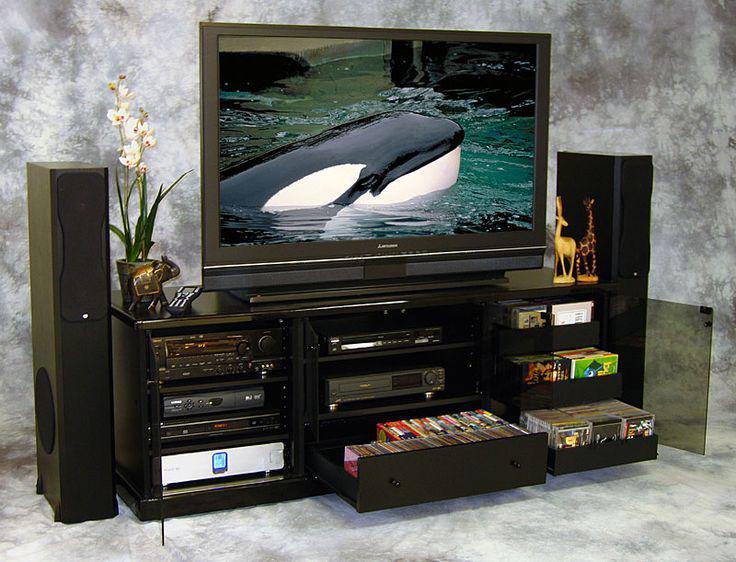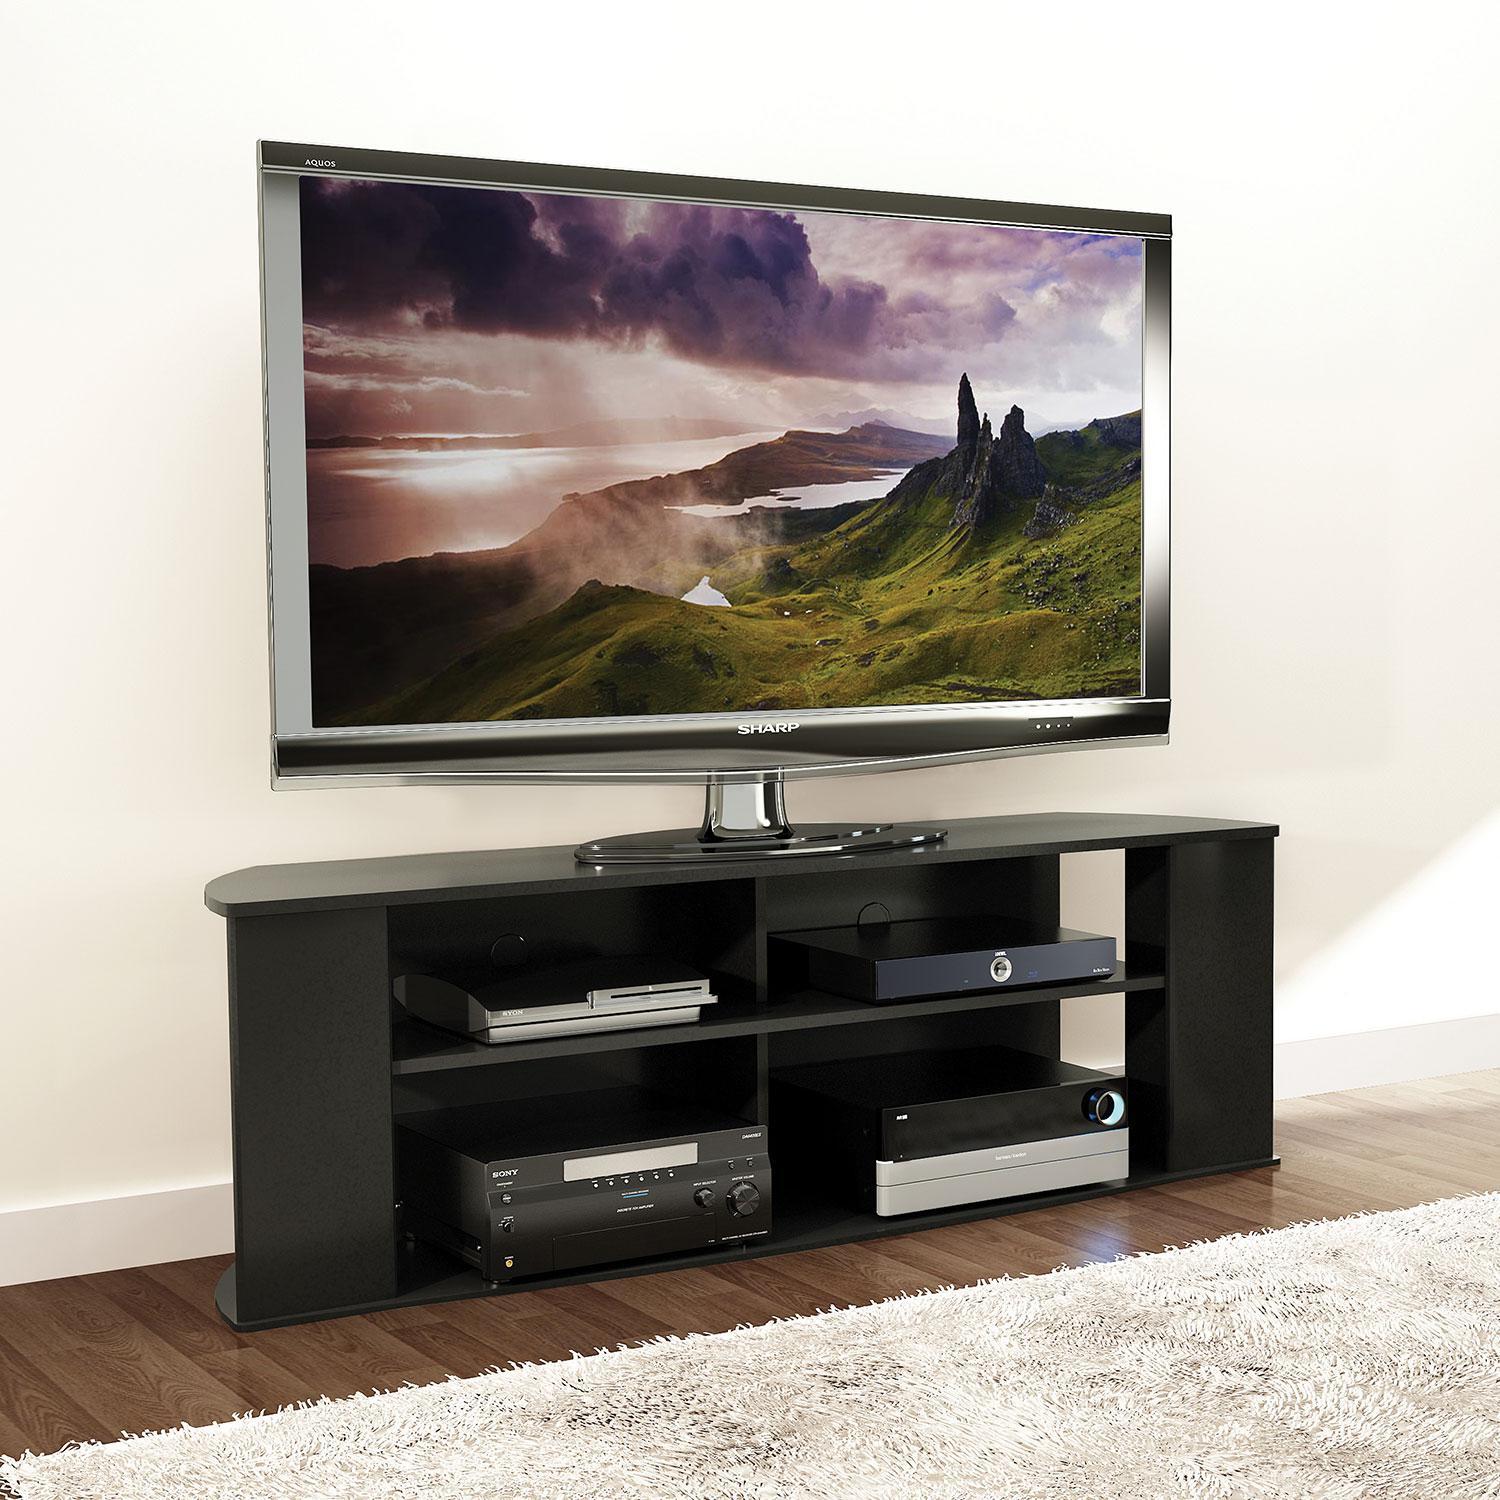The first image is the image on the left, the second image is the image on the right. For the images shown, is this caption "There are two people on the television on the left." true? Answer yes or no. No. 